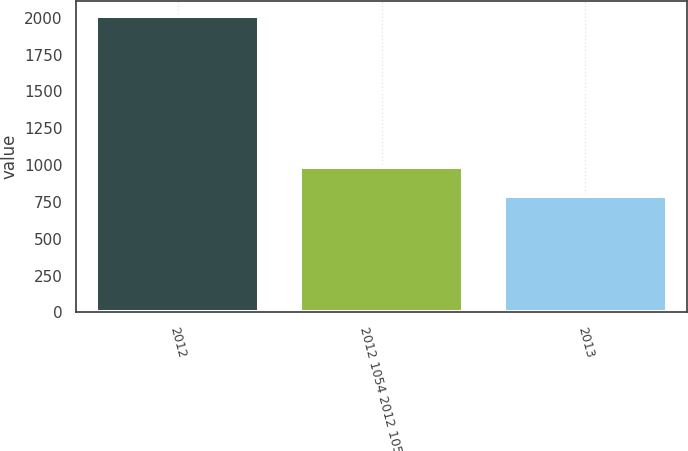Convert chart to OTSL. <chart><loc_0><loc_0><loc_500><loc_500><bar_chart><fcel>2012<fcel>2012 1054 2012 1054<fcel>2013<nl><fcel>2013<fcel>988<fcel>789<nl></chart> 